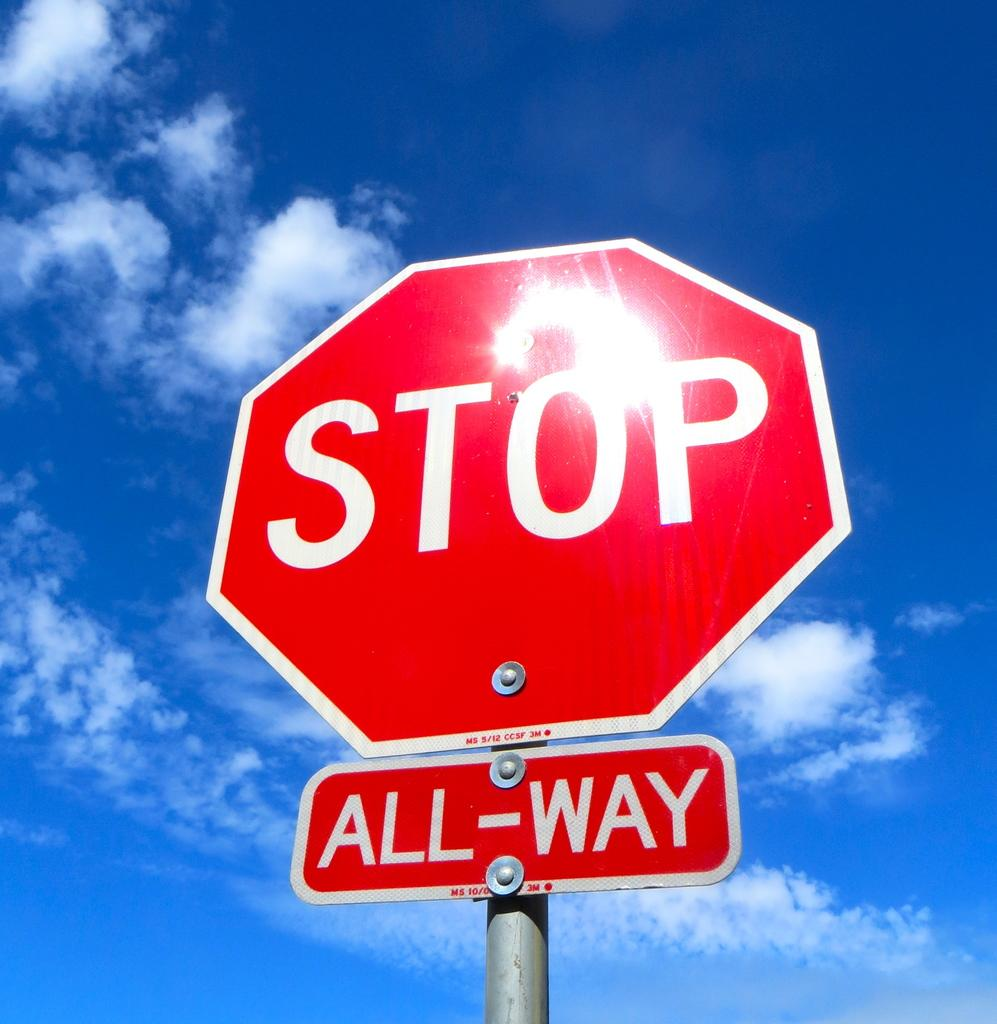<image>
Create a compact narrative representing the image presented. A stop sign is standing in front of the sun. 